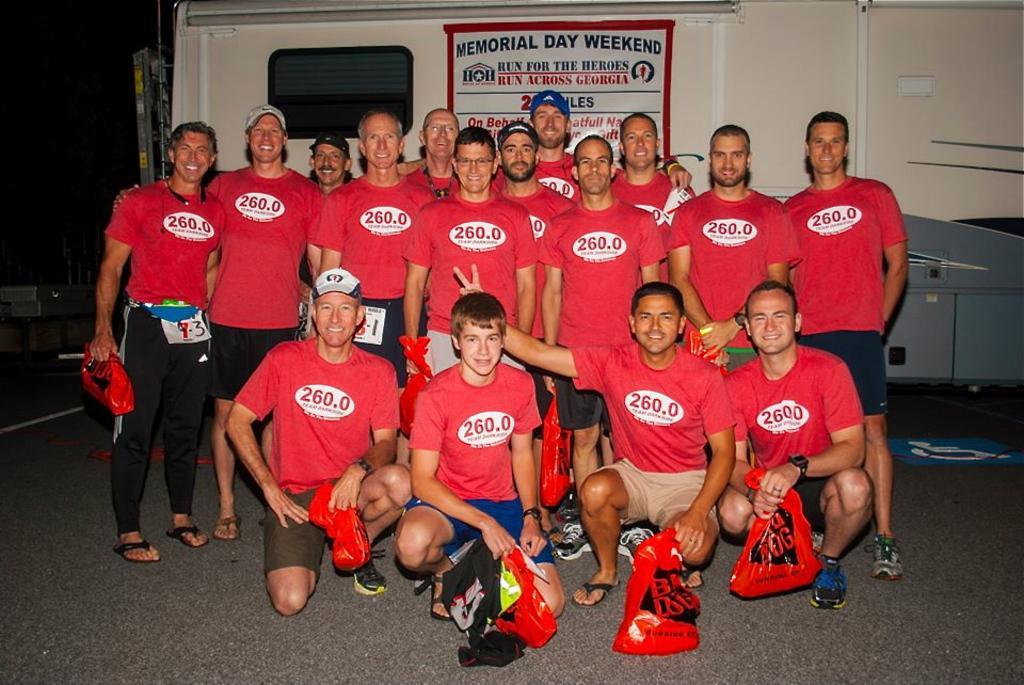Could you give a brief overview of what you see in this image? In this image we can see a few people, among them, some people are carrying the objects, behind them, we can see a vehicle, on the vehicle we can see some text. 